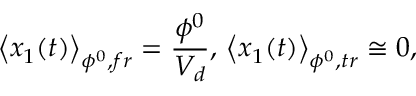Convert formula to latex. <formula><loc_0><loc_0><loc_500><loc_500>\left \langle x _ { 1 } ( t ) \right \rangle _ { \phi ^ { 0 } , f r } = \frac { \phi ^ { 0 } } { V _ { d } } , \, \left \langle x _ { 1 } ( t ) \right \rangle _ { \phi ^ { 0 } , t r } \cong 0 , \</formula> 